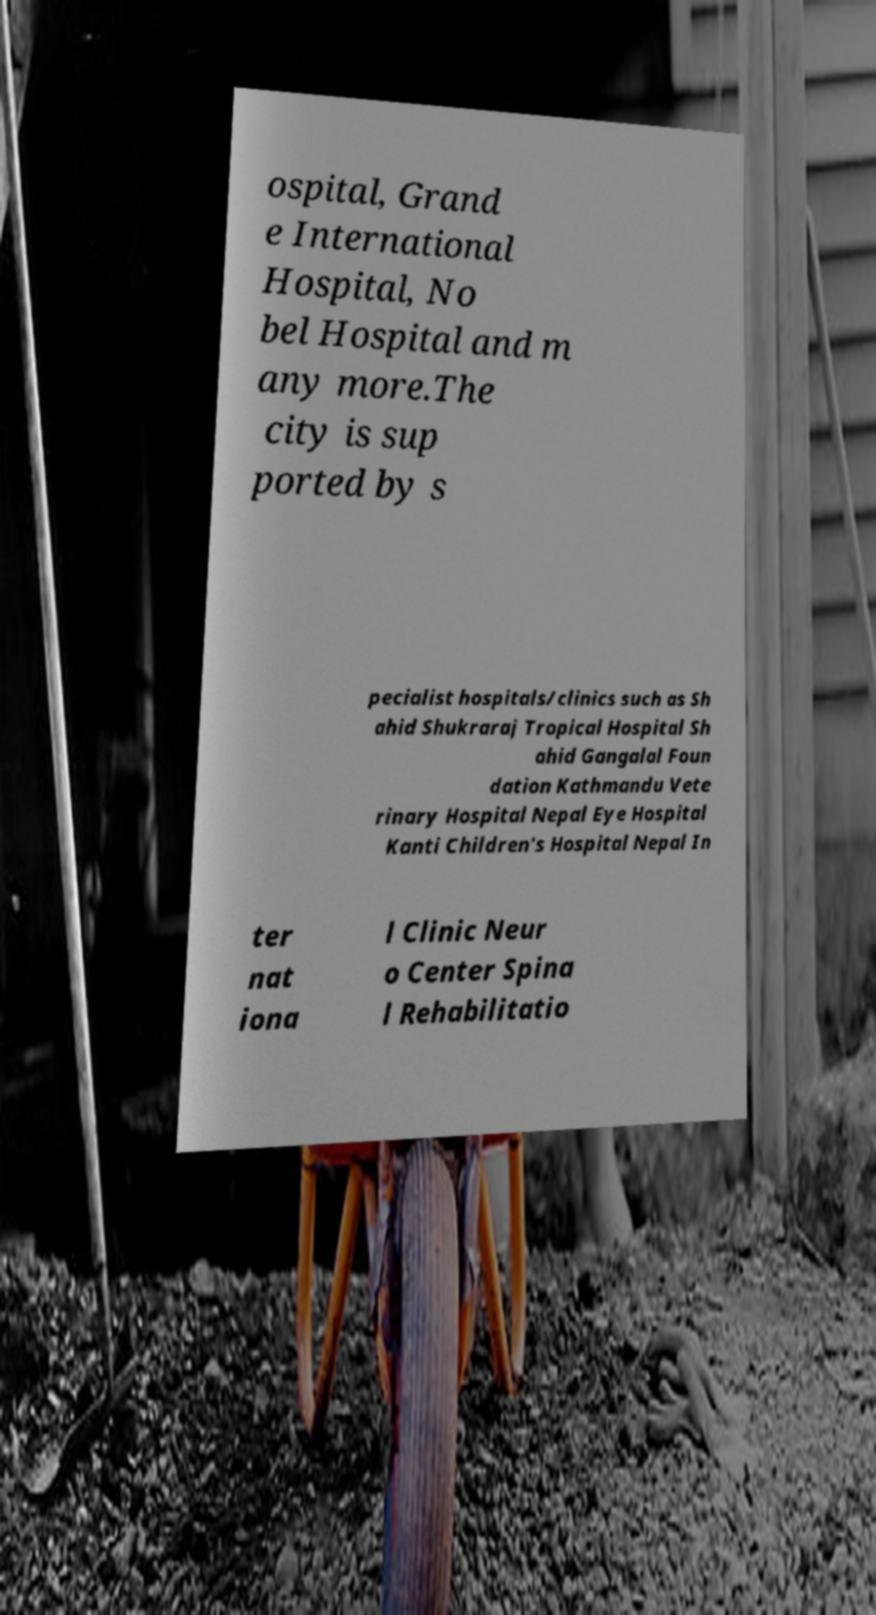For documentation purposes, I need the text within this image transcribed. Could you provide that? ospital, Grand e International Hospital, No bel Hospital and m any more.The city is sup ported by s pecialist hospitals/clinics such as Sh ahid Shukraraj Tropical Hospital Sh ahid Gangalal Foun dation Kathmandu Vete rinary Hospital Nepal Eye Hospital Kanti Children's Hospital Nepal In ter nat iona l Clinic Neur o Center Spina l Rehabilitatio 